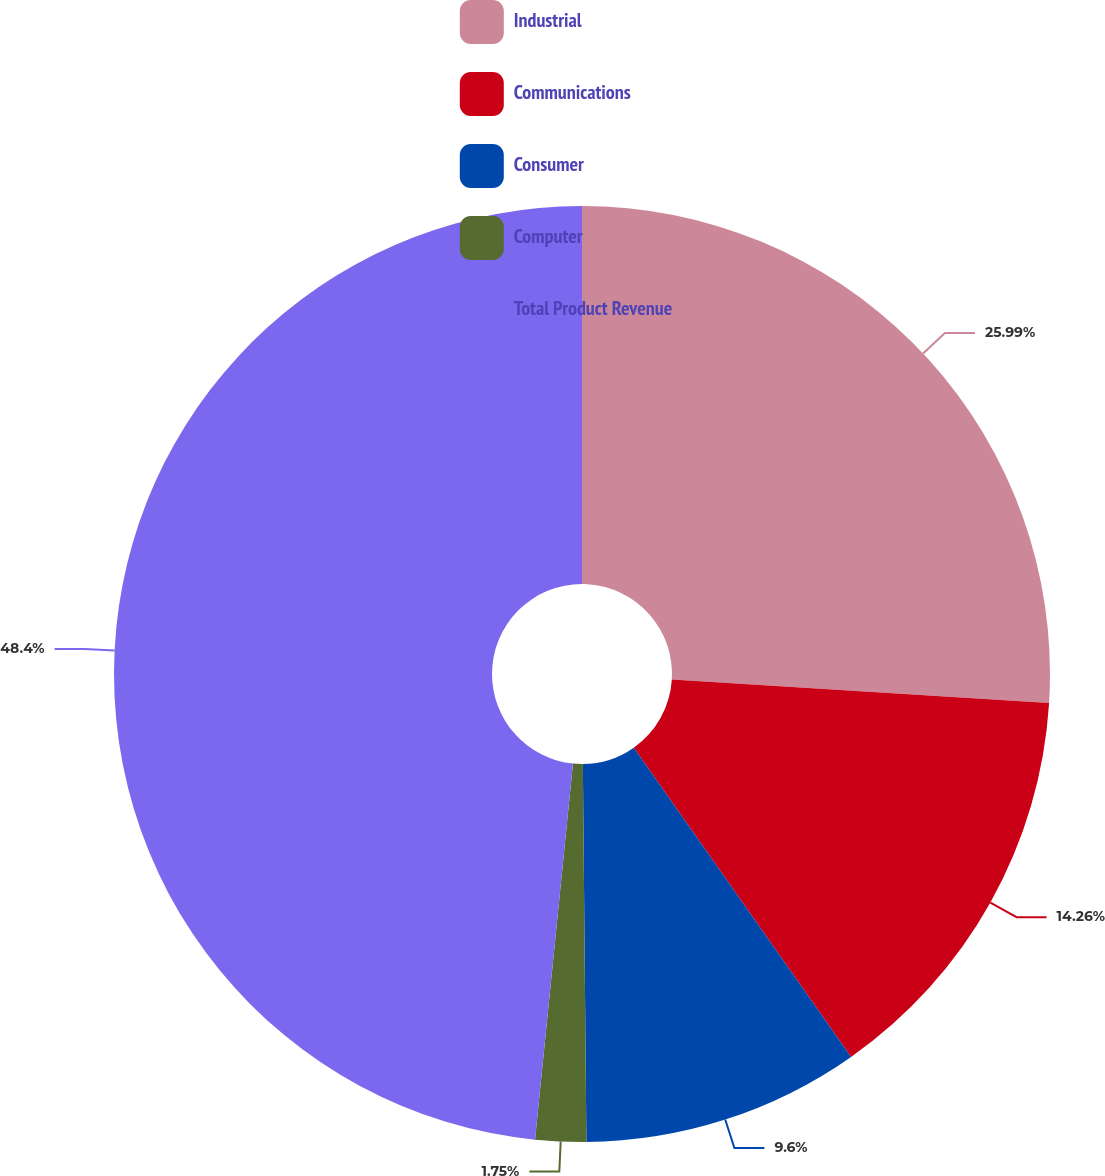Convert chart to OTSL. <chart><loc_0><loc_0><loc_500><loc_500><pie_chart><fcel>Industrial<fcel>Communications<fcel>Consumer<fcel>Computer<fcel>Total Product Revenue<nl><fcel>25.99%<fcel>14.26%<fcel>9.6%<fcel>1.75%<fcel>48.4%<nl></chart> 